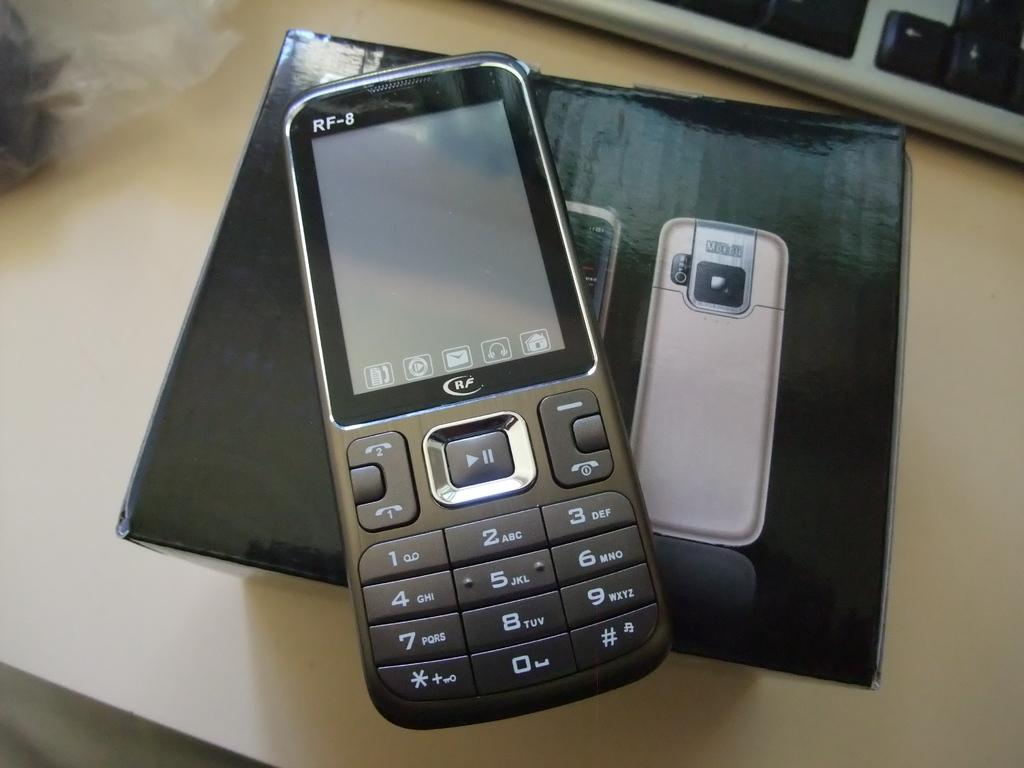<image>
Create a compact narrative representing the image presented. The number 7 key on the cellphone also contains the letters PQRS. 